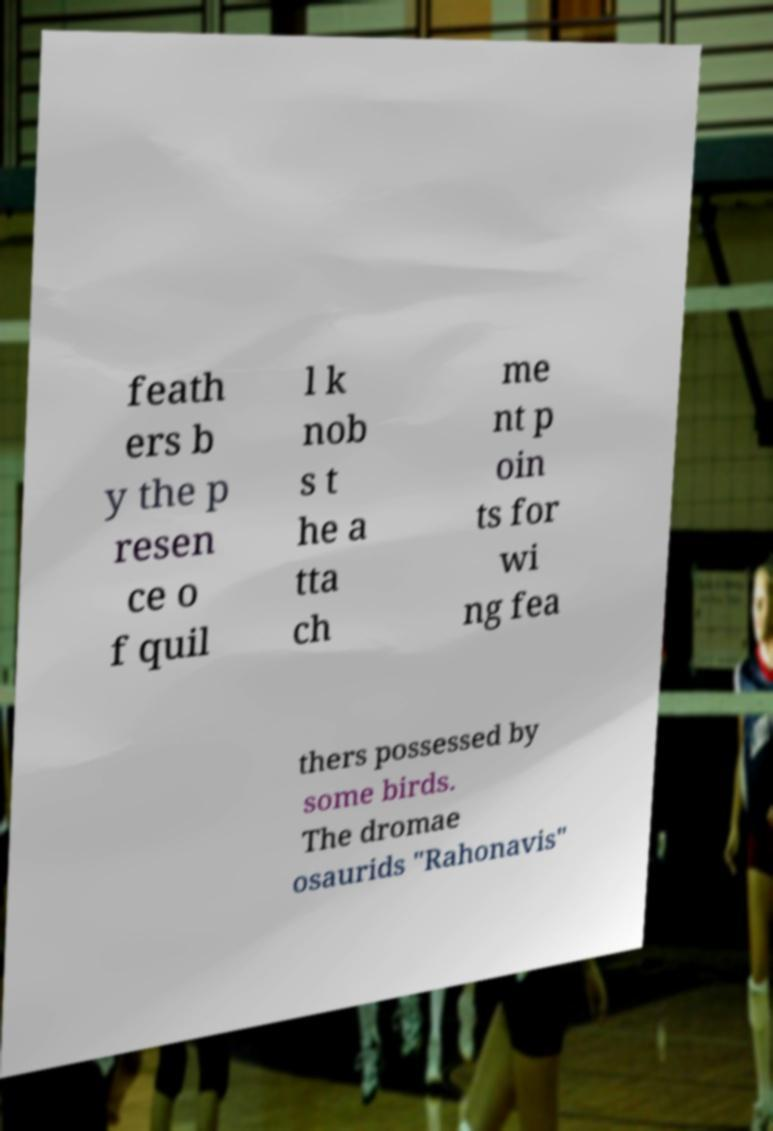Can you read and provide the text displayed in the image?This photo seems to have some interesting text. Can you extract and type it out for me? feath ers b y the p resen ce o f quil l k nob s t he a tta ch me nt p oin ts for wi ng fea thers possessed by some birds. The dromae osaurids "Rahonavis" 